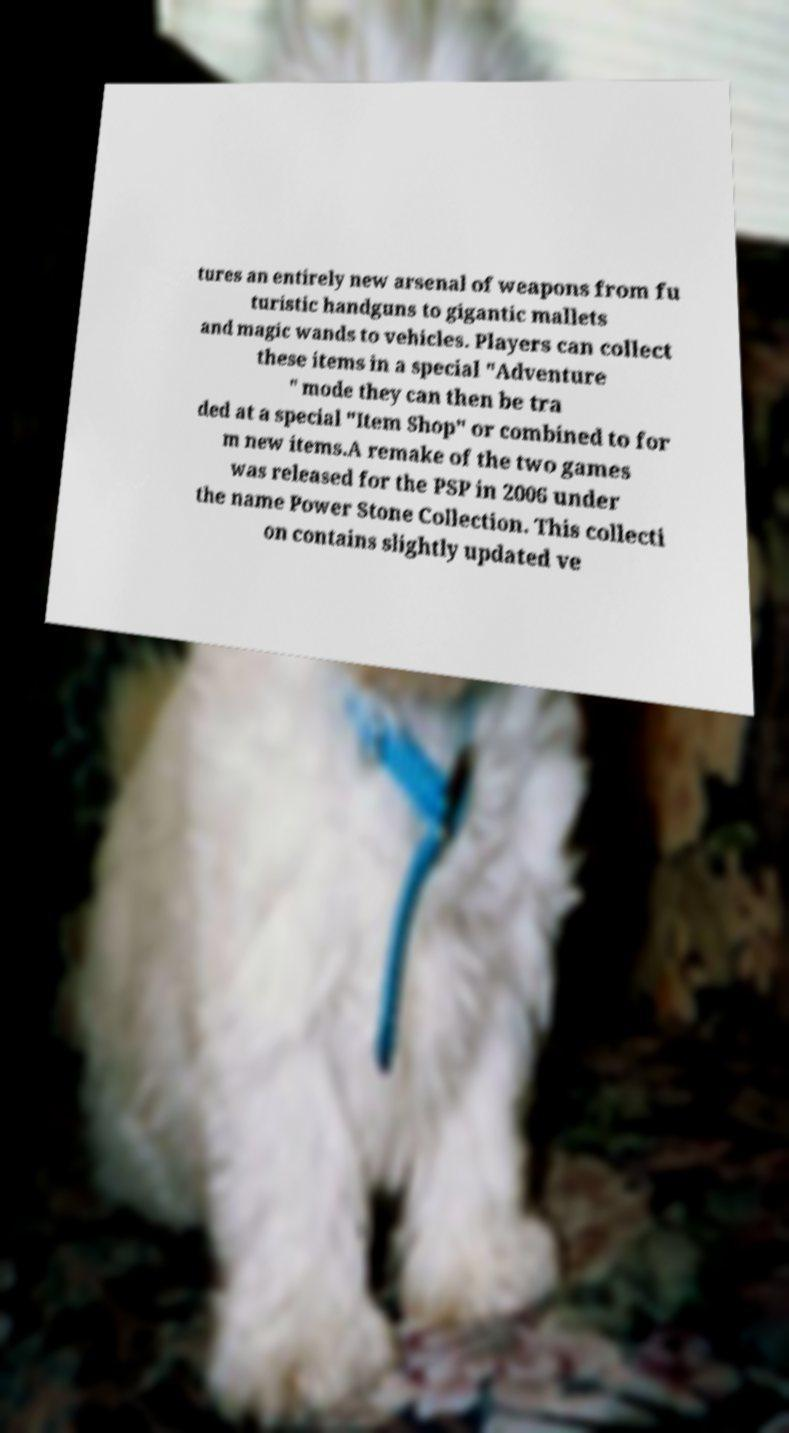I need the written content from this picture converted into text. Can you do that? tures an entirely new arsenal of weapons from fu turistic handguns to gigantic mallets and magic wands to vehicles. Players can collect these items in a special "Adventure " mode they can then be tra ded at a special "Item Shop" or combined to for m new items.A remake of the two games was released for the PSP in 2006 under the name Power Stone Collection. This collecti on contains slightly updated ve 